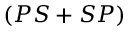<formula> <loc_0><loc_0><loc_500><loc_500>( P S + S P )</formula> 